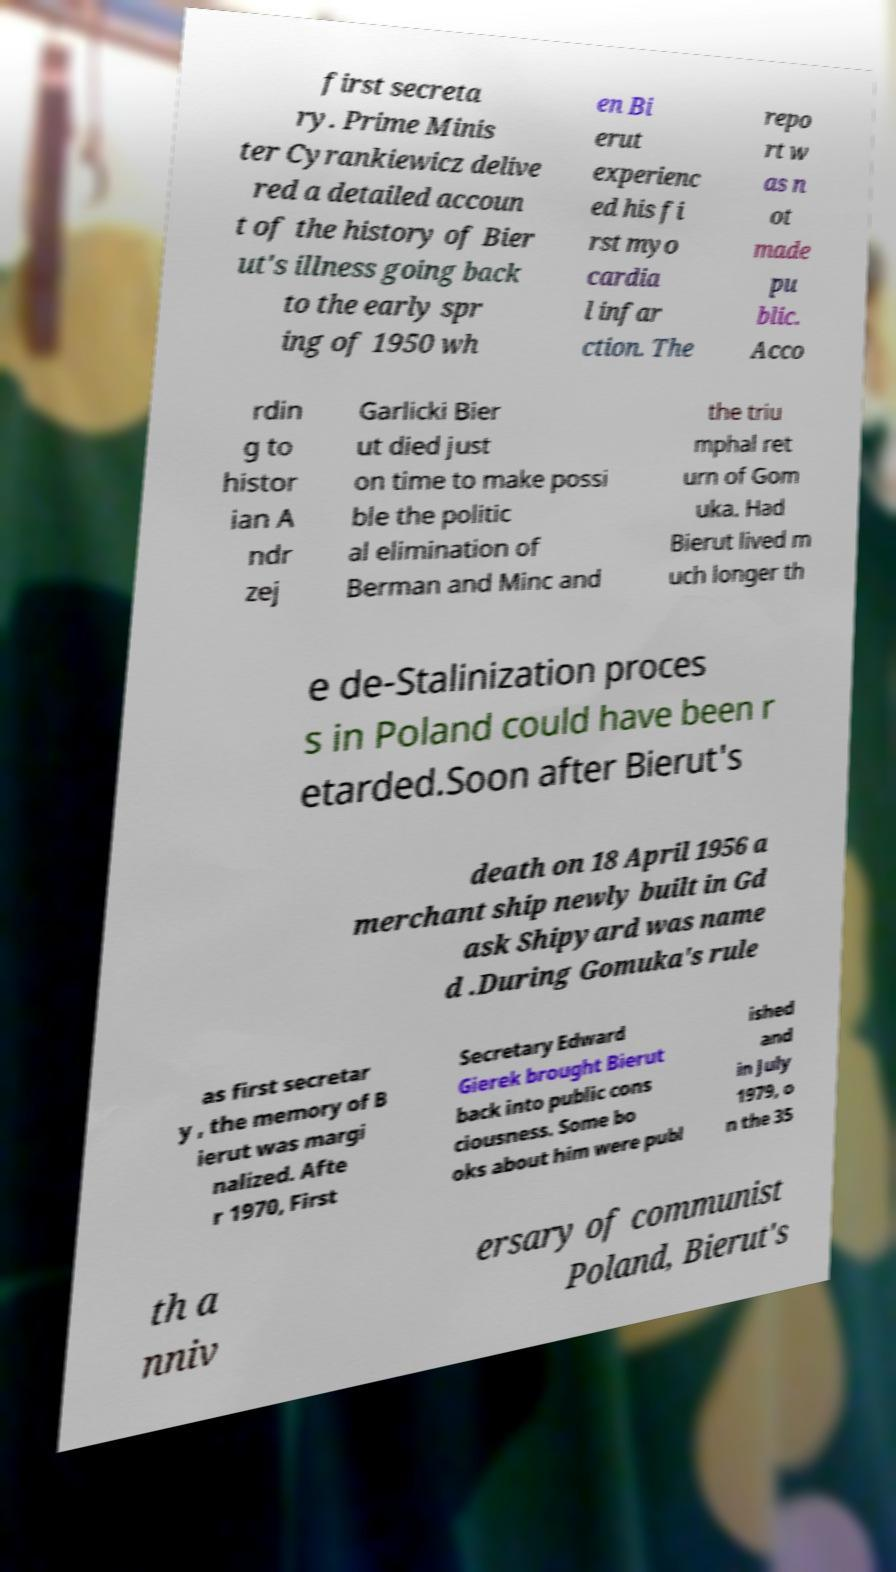What messages or text are displayed in this image? I need them in a readable, typed format. first secreta ry. Prime Minis ter Cyrankiewicz delive red a detailed accoun t of the history of Bier ut's illness going back to the early spr ing of 1950 wh en Bi erut experienc ed his fi rst myo cardia l infar ction. The repo rt w as n ot made pu blic. Acco rdin g to histor ian A ndr zej Garlicki Bier ut died just on time to make possi ble the politic al elimination of Berman and Minc and the triu mphal ret urn of Gom uka. Had Bierut lived m uch longer th e de-Stalinization proces s in Poland could have been r etarded.Soon after Bierut's death on 18 April 1956 a merchant ship newly built in Gd ask Shipyard was name d .During Gomuka's rule as first secretar y , the memory of B ierut was margi nalized. Afte r 1970, First Secretary Edward Gierek brought Bierut back into public cons ciousness. Some bo oks about him were publ ished and in July 1979, o n the 35 th a nniv ersary of communist Poland, Bierut's 